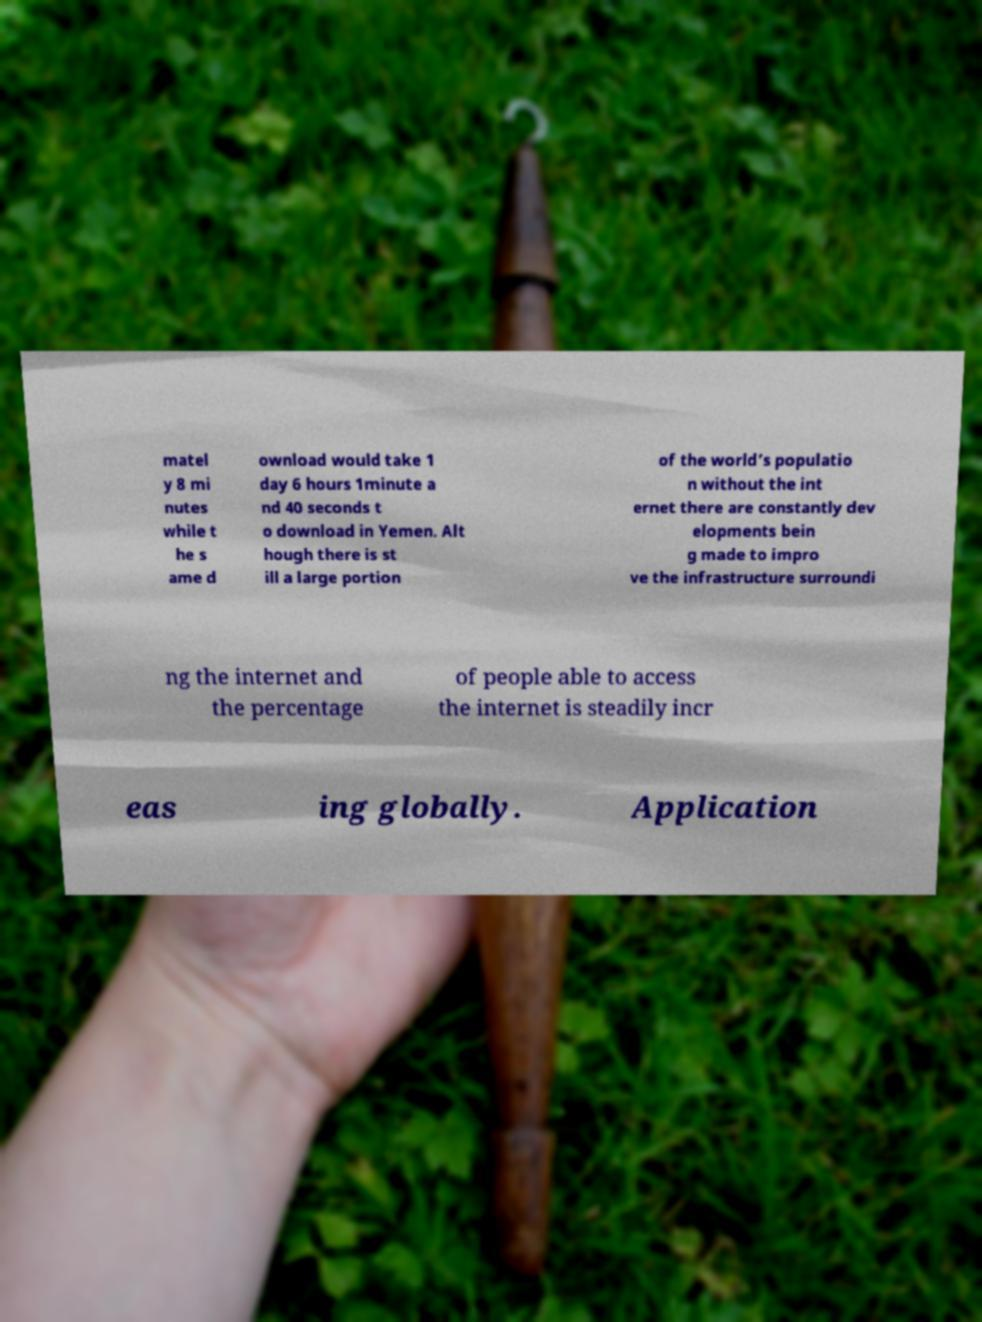For documentation purposes, I need the text within this image transcribed. Could you provide that? matel y 8 mi nutes while t he s ame d ownload would take 1 day 6 hours 1minute a nd 40 seconds t o download in Yemen. Alt hough there is st ill a large portion of the world’s populatio n without the int ernet there are constantly dev elopments bein g made to impro ve the infrastructure surroundi ng the internet and the percentage of people able to access the internet is steadily incr eas ing globally. Application 